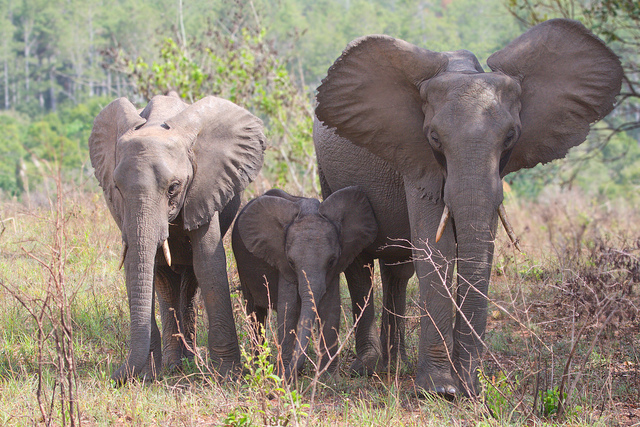How many elephants? 3 